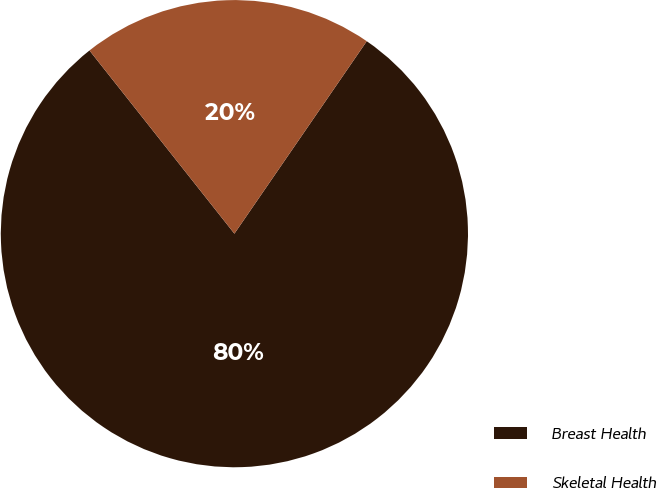Convert chart to OTSL. <chart><loc_0><loc_0><loc_500><loc_500><pie_chart><fcel>Breast Health<fcel>Skeletal Health<nl><fcel>79.76%<fcel>20.24%<nl></chart> 